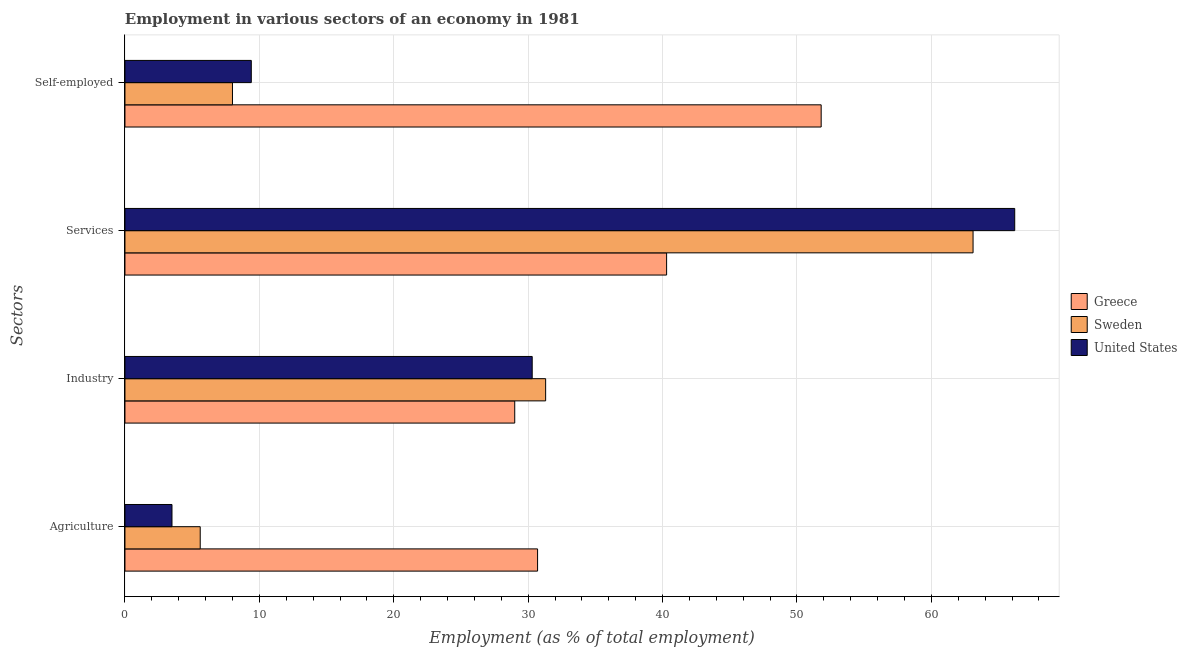How many groups of bars are there?
Ensure brevity in your answer.  4. How many bars are there on the 2nd tick from the top?
Provide a succinct answer. 3. How many bars are there on the 1st tick from the bottom?
Provide a short and direct response. 3. What is the label of the 4th group of bars from the top?
Provide a short and direct response. Agriculture. What is the percentage of workers in industry in Greece?
Your answer should be compact. 29. Across all countries, what is the maximum percentage of self employed workers?
Give a very brief answer. 51.8. Across all countries, what is the minimum percentage of workers in industry?
Offer a terse response. 29. What is the total percentage of workers in agriculture in the graph?
Make the answer very short. 39.8. What is the difference between the percentage of self employed workers in United States and that in Sweden?
Ensure brevity in your answer.  1.4. What is the difference between the percentage of workers in industry in Greece and the percentage of self employed workers in United States?
Your answer should be compact. 19.6. What is the average percentage of self employed workers per country?
Offer a terse response. 23.07. What is the difference between the percentage of self employed workers and percentage of workers in agriculture in United States?
Make the answer very short. 5.9. What is the ratio of the percentage of workers in services in Sweden to that in United States?
Offer a terse response. 0.95. Is the percentage of workers in industry in Sweden less than that in Greece?
Give a very brief answer. No. What is the difference between the highest and the second highest percentage of self employed workers?
Provide a short and direct response. 42.4. What is the difference between the highest and the lowest percentage of workers in agriculture?
Provide a short and direct response. 27.2. In how many countries, is the percentage of workers in services greater than the average percentage of workers in services taken over all countries?
Provide a succinct answer. 2. Is it the case that in every country, the sum of the percentage of workers in services and percentage of workers in agriculture is greater than the sum of percentage of self employed workers and percentage of workers in industry?
Your answer should be compact. Yes. What does the 3rd bar from the top in Self-employed represents?
Offer a very short reply. Greece. What does the 2nd bar from the bottom in Agriculture represents?
Provide a succinct answer. Sweden. How many bars are there?
Offer a very short reply. 12. Are all the bars in the graph horizontal?
Provide a succinct answer. Yes. How many countries are there in the graph?
Provide a short and direct response. 3. Does the graph contain grids?
Your answer should be very brief. Yes. Where does the legend appear in the graph?
Offer a very short reply. Center right. How many legend labels are there?
Ensure brevity in your answer.  3. What is the title of the graph?
Make the answer very short. Employment in various sectors of an economy in 1981. What is the label or title of the X-axis?
Keep it short and to the point. Employment (as % of total employment). What is the label or title of the Y-axis?
Make the answer very short. Sectors. What is the Employment (as % of total employment) in Greece in Agriculture?
Make the answer very short. 30.7. What is the Employment (as % of total employment) of Sweden in Agriculture?
Your answer should be very brief. 5.6. What is the Employment (as % of total employment) in Sweden in Industry?
Provide a short and direct response. 31.3. What is the Employment (as % of total employment) of United States in Industry?
Give a very brief answer. 30.3. What is the Employment (as % of total employment) of Greece in Services?
Your answer should be compact. 40.3. What is the Employment (as % of total employment) in Sweden in Services?
Your answer should be very brief. 63.1. What is the Employment (as % of total employment) in United States in Services?
Offer a very short reply. 66.2. What is the Employment (as % of total employment) in Greece in Self-employed?
Make the answer very short. 51.8. What is the Employment (as % of total employment) in Sweden in Self-employed?
Your answer should be compact. 8. What is the Employment (as % of total employment) in United States in Self-employed?
Keep it short and to the point. 9.4. Across all Sectors, what is the maximum Employment (as % of total employment) of Greece?
Ensure brevity in your answer.  51.8. Across all Sectors, what is the maximum Employment (as % of total employment) in Sweden?
Make the answer very short. 63.1. Across all Sectors, what is the maximum Employment (as % of total employment) of United States?
Keep it short and to the point. 66.2. Across all Sectors, what is the minimum Employment (as % of total employment) in Sweden?
Ensure brevity in your answer.  5.6. What is the total Employment (as % of total employment) in Greece in the graph?
Offer a very short reply. 151.8. What is the total Employment (as % of total employment) in Sweden in the graph?
Your answer should be very brief. 108. What is the total Employment (as % of total employment) of United States in the graph?
Your answer should be very brief. 109.4. What is the difference between the Employment (as % of total employment) of Greece in Agriculture and that in Industry?
Your answer should be compact. 1.7. What is the difference between the Employment (as % of total employment) of Sweden in Agriculture and that in Industry?
Your response must be concise. -25.7. What is the difference between the Employment (as % of total employment) in United States in Agriculture and that in Industry?
Give a very brief answer. -26.8. What is the difference between the Employment (as % of total employment) of Greece in Agriculture and that in Services?
Offer a very short reply. -9.6. What is the difference between the Employment (as % of total employment) of Sweden in Agriculture and that in Services?
Give a very brief answer. -57.5. What is the difference between the Employment (as % of total employment) in United States in Agriculture and that in Services?
Keep it short and to the point. -62.7. What is the difference between the Employment (as % of total employment) of Greece in Agriculture and that in Self-employed?
Your answer should be compact. -21.1. What is the difference between the Employment (as % of total employment) of Sweden in Agriculture and that in Self-employed?
Offer a very short reply. -2.4. What is the difference between the Employment (as % of total employment) of United States in Agriculture and that in Self-employed?
Your answer should be compact. -5.9. What is the difference between the Employment (as % of total employment) of Sweden in Industry and that in Services?
Give a very brief answer. -31.8. What is the difference between the Employment (as % of total employment) in United States in Industry and that in Services?
Offer a very short reply. -35.9. What is the difference between the Employment (as % of total employment) in Greece in Industry and that in Self-employed?
Offer a very short reply. -22.8. What is the difference between the Employment (as % of total employment) of Sweden in Industry and that in Self-employed?
Your response must be concise. 23.3. What is the difference between the Employment (as % of total employment) in United States in Industry and that in Self-employed?
Provide a short and direct response. 20.9. What is the difference between the Employment (as % of total employment) of Sweden in Services and that in Self-employed?
Give a very brief answer. 55.1. What is the difference between the Employment (as % of total employment) in United States in Services and that in Self-employed?
Provide a succinct answer. 56.8. What is the difference between the Employment (as % of total employment) of Greece in Agriculture and the Employment (as % of total employment) of United States in Industry?
Keep it short and to the point. 0.4. What is the difference between the Employment (as % of total employment) of Sweden in Agriculture and the Employment (as % of total employment) of United States in Industry?
Your response must be concise. -24.7. What is the difference between the Employment (as % of total employment) of Greece in Agriculture and the Employment (as % of total employment) of Sweden in Services?
Provide a succinct answer. -32.4. What is the difference between the Employment (as % of total employment) in Greece in Agriculture and the Employment (as % of total employment) in United States in Services?
Offer a terse response. -35.5. What is the difference between the Employment (as % of total employment) in Sweden in Agriculture and the Employment (as % of total employment) in United States in Services?
Offer a very short reply. -60.6. What is the difference between the Employment (as % of total employment) of Greece in Agriculture and the Employment (as % of total employment) of Sweden in Self-employed?
Ensure brevity in your answer.  22.7. What is the difference between the Employment (as % of total employment) in Greece in Agriculture and the Employment (as % of total employment) in United States in Self-employed?
Offer a very short reply. 21.3. What is the difference between the Employment (as % of total employment) of Sweden in Agriculture and the Employment (as % of total employment) of United States in Self-employed?
Provide a short and direct response. -3.8. What is the difference between the Employment (as % of total employment) in Greece in Industry and the Employment (as % of total employment) in Sweden in Services?
Keep it short and to the point. -34.1. What is the difference between the Employment (as % of total employment) in Greece in Industry and the Employment (as % of total employment) in United States in Services?
Your response must be concise. -37.2. What is the difference between the Employment (as % of total employment) in Sweden in Industry and the Employment (as % of total employment) in United States in Services?
Offer a very short reply. -34.9. What is the difference between the Employment (as % of total employment) in Greece in Industry and the Employment (as % of total employment) in Sweden in Self-employed?
Your answer should be very brief. 21. What is the difference between the Employment (as % of total employment) in Greece in Industry and the Employment (as % of total employment) in United States in Self-employed?
Ensure brevity in your answer.  19.6. What is the difference between the Employment (as % of total employment) in Sweden in Industry and the Employment (as % of total employment) in United States in Self-employed?
Your answer should be very brief. 21.9. What is the difference between the Employment (as % of total employment) of Greece in Services and the Employment (as % of total employment) of Sweden in Self-employed?
Ensure brevity in your answer.  32.3. What is the difference between the Employment (as % of total employment) of Greece in Services and the Employment (as % of total employment) of United States in Self-employed?
Ensure brevity in your answer.  30.9. What is the difference between the Employment (as % of total employment) of Sweden in Services and the Employment (as % of total employment) of United States in Self-employed?
Make the answer very short. 53.7. What is the average Employment (as % of total employment) of Greece per Sectors?
Provide a short and direct response. 37.95. What is the average Employment (as % of total employment) of United States per Sectors?
Your answer should be compact. 27.35. What is the difference between the Employment (as % of total employment) of Greece and Employment (as % of total employment) of Sweden in Agriculture?
Ensure brevity in your answer.  25.1. What is the difference between the Employment (as % of total employment) in Greece and Employment (as % of total employment) in United States in Agriculture?
Your answer should be compact. 27.2. What is the difference between the Employment (as % of total employment) in Greece and Employment (as % of total employment) in Sweden in Industry?
Your answer should be very brief. -2.3. What is the difference between the Employment (as % of total employment) in Greece and Employment (as % of total employment) in United States in Industry?
Provide a short and direct response. -1.3. What is the difference between the Employment (as % of total employment) in Sweden and Employment (as % of total employment) in United States in Industry?
Give a very brief answer. 1. What is the difference between the Employment (as % of total employment) of Greece and Employment (as % of total employment) of Sweden in Services?
Offer a very short reply. -22.8. What is the difference between the Employment (as % of total employment) in Greece and Employment (as % of total employment) in United States in Services?
Keep it short and to the point. -25.9. What is the difference between the Employment (as % of total employment) in Greece and Employment (as % of total employment) in Sweden in Self-employed?
Give a very brief answer. 43.8. What is the difference between the Employment (as % of total employment) in Greece and Employment (as % of total employment) in United States in Self-employed?
Keep it short and to the point. 42.4. What is the ratio of the Employment (as % of total employment) in Greece in Agriculture to that in Industry?
Your answer should be compact. 1.06. What is the ratio of the Employment (as % of total employment) of Sweden in Agriculture to that in Industry?
Offer a terse response. 0.18. What is the ratio of the Employment (as % of total employment) in United States in Agriculture to that in Industry?
Provide a short and direct response. 0.12. What is the ratio of the Employment (as % of total employment) of Greece in Agriculture to that in Services?
Keep it short and to the point. 0.76. What is the ratio of the Employment (as % of total employment) in Sweden in Agriculture to that in Services?
Keep it short and to the point. 0.09. What is the ratio of the Employment (as % of total employment) of United States in Agriculture to that in Services?
Offer a terse response. 0.05. What is the ratio of the Employment (as % of total employment) of Greece in Agriculture to that in Self-employed?
Provide a succinct answer. 0.59. What is the ratio of the Employment (as % of total employment) of Sweden in Agriculture to that in Self-employed?
Offer a very short reply. 0.7. What is the ratio of the Employment (as % of total employment) in United States in Agriculture to that in Self-employed?
Give a very brief answer. 0.37. What is the ratio of the Employment (as % of total employment) in Greece in Industry to that in Services?
Make the answer very short. 0.72. What is the ratio of the Employment (as % of total employment) in Sweden in Industry to that in Services?
Keep it short and to the point. 0.5. What is the ratio of the Employment (as % of total employment) in United States in Industry to that in Services?
Give a very brief answer. 0.46. What is the ratio of the Employment (as % of total employment) of Greece in Industry to that in Self-employed?
Provide a succinct answer. 0.56. What is the ratio of the Employment (as % of total employment) in Sweden in Industry to that in Self-employed?
Provide a succinct answer. 3.91. What is the ratio of the Employment (as % of total employment) in United States in Industry to that in Self-employed?
Offer a very short reply. 3.22. What is the ratio of the Employment (as % of total employment) in Greece in Services to that in Self-employed?
Your answer should be very brief. 0.78. What is the ratio of the Employment (as % of total employment) of Sweden in Services to that in Self-employed?
Offer a very short reply. 7.89. What is the ratio of the Employment (as % of total employment) of United States in Services to that in Self-employed?
Provide a succinct answer. 7.04. What is the difference between the highest and the second highest Employment (as % of total employment) of Sweden?
Keep it short and to the point. 31.8. What is the difference between the highest and the second highest Employment (as % of total employment) in United States?
Ensure brevity in your answer.  35.9. What is the difference between the highest and the lowest Employment (as % of total employment) of Greece?
Ensure brevity in your answer.  22.8. What is the difference between the highest and the lowest Employment (as % of total employment) in Sweden?
Give a very brief answer. 57.5. What is the difference between the highest and the lowest Employment (as % of total employment) in United States?
Your response must be concise. 62.7. 